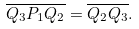<formula> <loc_0><loc_0><loc_500><loc_500>\overline { Q _ { 3 } P _ { 1 } Q _ { 2 } } = \overline { Q _ { 2 } Q _ { 3 } } .</formula> 